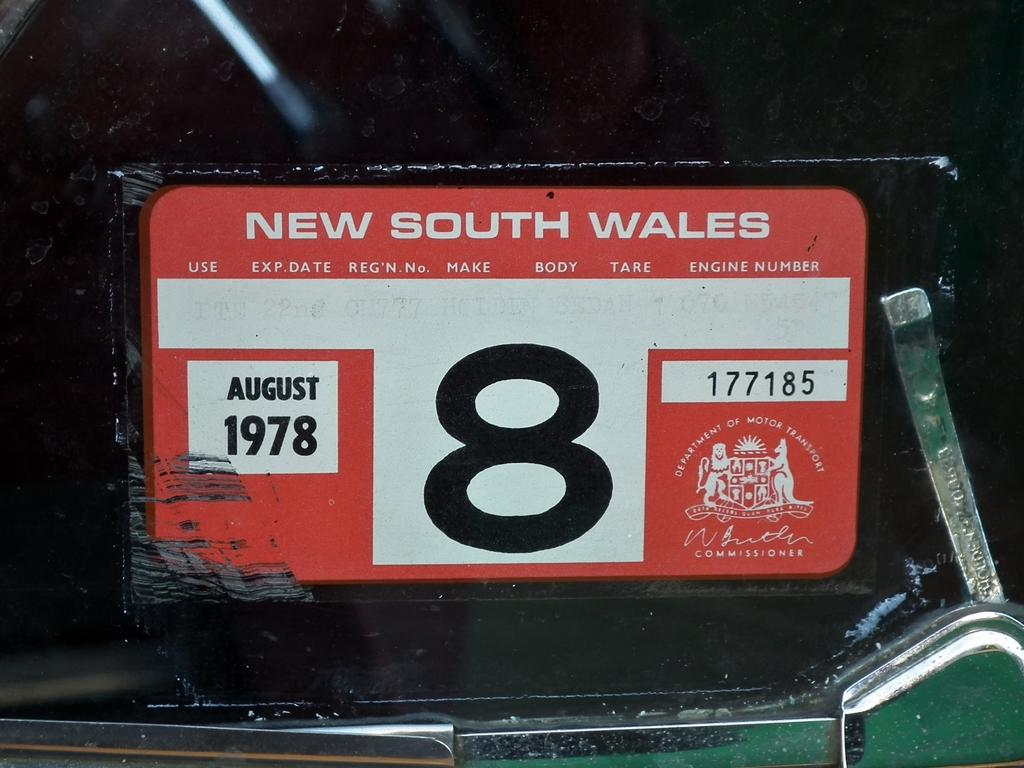<image>
Offer a succinct explanation of the picture presented. Some sort of identification plate from NEW SOUTH WALES with the number 8. 